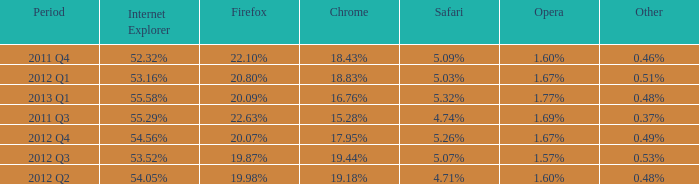Parse the table in full. {'header': ['Period', 'Internet Explorer', 'Firefox', 'Chrome', 'Safari', 'Opera', 'Other'], 'rows': [['2011 Q4', '52.32%', '22.10%', '18.43%', '5.09%', '1.60%', '0.46%'], ['2012 Q1', '53.16%', '20.80%', '18.83%', '5.03%', '1.67%', '0.51%'], ['2013 Q1', '55.58%', '20.09%', '16.76%', '5.32%', '1.77%', '0.48%'], ['2011 Q3', '55.29%', '22.63%', '15.28%', '4.74%', '1.69%', '0.37%'], ['2012 Q4', '54.56%', '20.07%', '17.95%', '5.26%', '1.67%', '0.49%'], ['2012 Q3', '53.52%', '19.87%', '19.44%', '5.07%', '1.57%', '0.53%'], ['2012 Q2', '54.05%', '19.98%', '19.18%', '4.71%', '1.60%', '0.48%']]} What opera has 19.87% as the firefox? 1.57%. 